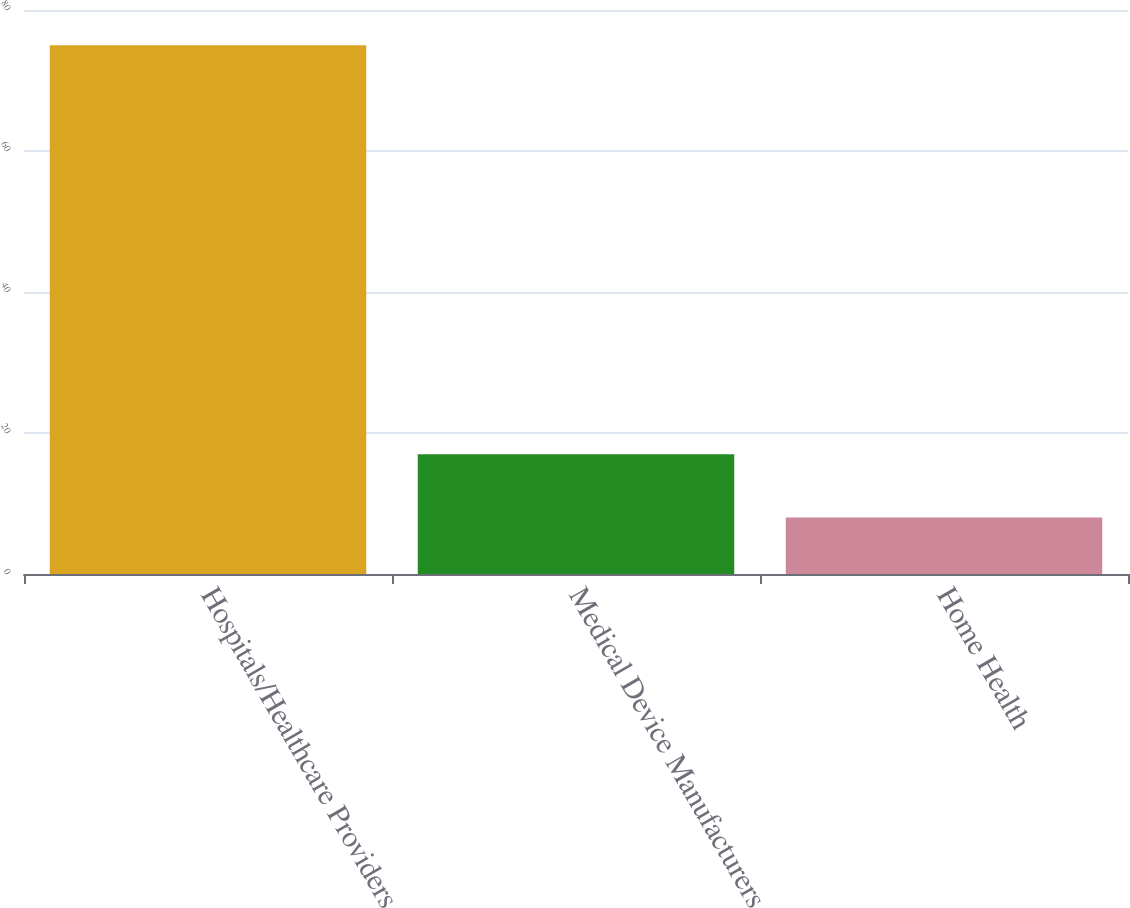Convert chart. <chart><loc_0><loc_0><loc_500><loc_500><bar_chart><fcel>Hospitals/Healthcare Providers<fcel>Medical Device Manufacturers<fcel>Home Health<nl><fcel>75<fcel>17<fcel>8<nl></chart> 